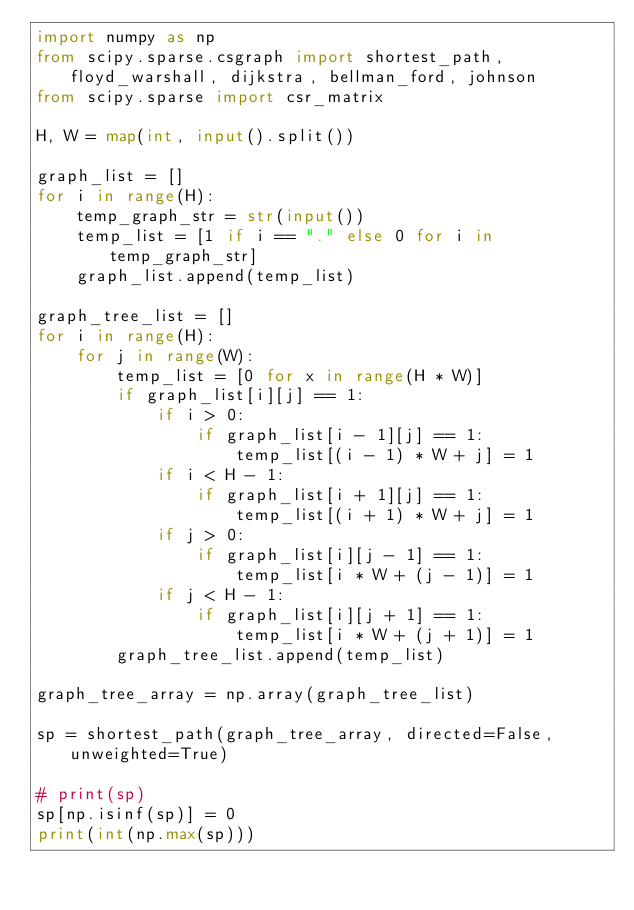Convert code to text. <code><loc_0><loc_0><loc_500><loc_500><_Python_>import numpy as np
from scipy.sparse.csgraph import shortest_path, floyd_warshall, dijkstra, bellman_ford, johnson
from scipy.sparse import csr_matrix

H, W = map(int, input().split())

graph_list = []
for i in range(H):
    temp_graph_str = str(input())
    temp_list = [1 if i == "." else 0 for i in temp_graph_str]
    graph_list.append(temp_list)

graph_tree_list = []
for i in range(H):
    for j in range(W):
        temp_list = [0 for x in range(H * W)]
        if graph_list[i][j] == 1:
            if i > 0:
                if graph_list[i - 1][j] == 1:
                    temp_list[(i - 1) * W + j] = 1
            if i < H - 1:
                if graph_list[i + 1][j] == 1:
                    temp_list[(i + 1) * W + j] = 1
            if j > 0:
                if graph_list[i][j - 1] == 1:
                    temp_list[i * W + (j - 1)] = 1
            if j < H - 1:
                if graph_list[i][j + 1] == 1:
                    temp_list[i * W + (j + 1)] = 1
        graph_tree_list.append(temp_list)

graph_tree_array = np.array(graph_tree_list)

sp = shortest_path(graph_tree_array, directed=False, unweighted=True)

# print(sp)
sp[np.isinf(sp)] = 0
print(int(np.max(sp)))</code> 